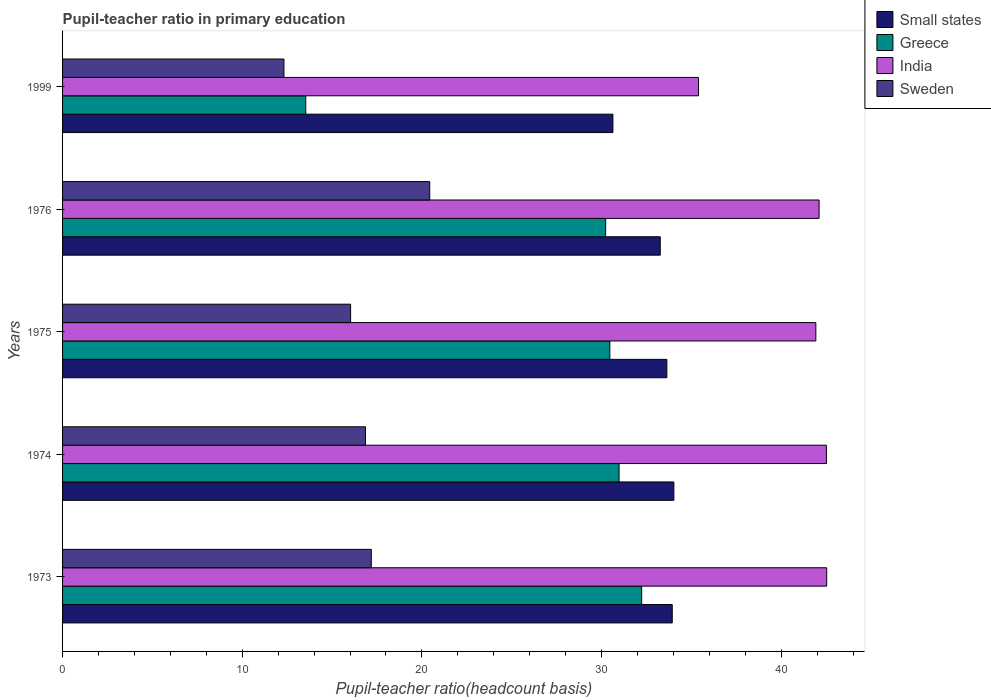Are the number of bars per tick equal to the number of legend labels?
Your answer should be very brief. Yes. Are the number of bars on each tick of the Y-axis equal?
Your answer should be very brief. Yes. How many bars are there on the 1st tick from the bottom?
Provide a short and direct response. 4. What is the label of the 5th group of bars from the top?
Ensure brevity in your answer.  1973. What is the pupil-teacher ratio in primary education in Small states in 1999?
Provide a succinct answer. 30.64. Across all years, what is the maximum pupil-teacher ratio in primary education in Small states?
Ensure brevity in your answer.  34.03. Across all years, what is the minimum pupil-teacher ratio in primary education in India?
Ensure brevity in your answer.  35.4. In which year was the pupil-teacher ratio in primary education in Small states maximum?
Provide a short and direct response. 1974. In which year was the pupil-teacher ratio in primary education in Small states minimum?
Your answer should be very brief. 1999. What is the total pupil-teacher ratio in primary education in India in the graph?
Make the answer very short. 204.5. What is the difference between the pupil-teacher ratio in primary education in Small states in 1973 and that in 1976?
Ensure brevity in your answer.  0.67. What is the difference between the pupil-teacher ratio in primary education in Small states in 1975 and the pupil-teacher ratio in primary education in India in 1976?
Ensure brevity in your answer.  -8.47. What is the average pupil-teacher ratio in primary education in Small states per year?
Give a very brief answer. 33.1. In the year 1975, what is the difference between the pupil-teacher ratio in primary education in India and pupil-teacher ratio in primary education in Sweden?
Give a very brief answer. 25.9. In how many years, is the pupil-teacher ratio in primary education in India greater than 40 ?
Your response must be concise. 4. What is the ratio of the pupil-teacher ratio in primary education in India in 1976 to that in 1999?
Your response must be concise. 1.19. Is the pupil-teacher ratio in primary education in Small states in 1973 less than that in 1976?
Give a very brief answer. No. Is the difference between the pupil-teacher ratio in primary education in India in 1973 and 1975 greater than the difference between the pupil-teacher ratio in primary education in Sweden in 1973 and 1975?
Give a very brief answer. No. What is the difference between the highest and the second highest pupil-teacher ratio in primary education in India?
Keep it short and to the point. 0.02. What is the difference between the highest and the lowest pupil-teacher ratio in primary education in India?
Keep it short and to the point. 7.14. In how many years, is the pupil-teacher ratio in primary education in Sweden greater than the average pupil-teacher ratio in primary education in Sweden taken over all years?
Make the answer very short. 3. Is the sum of the pupil-teacher ratio in primary education in Sweden in 1974 and 1975 greater than the maximum pupil-teacher ratio in primary education in Greece across all years?
Give a very brief answer. Yes. Is it the case that in every year, the sum of the pupil-teacher ratio in primary education in Sweden and pupil-teacher ratio in primary education in Greece is greater than the pupil-teacher ratio in primary education in Small states?
Provide a short and direct response. No. How many bars are there?
Make the answer very short. 20. How many years are there in the graph?
Ensure brevity in your answer.  5. What is the difference between two consecutive major ticks on the X-axis?
Give a very brief answer. 10. Are the values on the major ticks of X-axis written in scientific E-notation?
Offer a terse response. No. Does the graph contain grids?
Give a very brief answer. No. How are the legend labels stacked?
Give a very brief answer. Vertical. What is the title of the graph?
Offer a terse response. Pupil-teacher ratio in primary education. Does "Oman" appear as one of the legend labels in the graph?
Offer a very short reply. No. What is the label or title of the X-axis?
Ensure brevity in your answer.  Pupil-teacher ratio(headcount basis). What is the Pupil-teacher ratio(headcount basis) in Small states in 1973?
Provide a short and direct response. 33.94. What is the Pupil-teacher ratio(headcount basis) of Greece in 1973?
Provide a succinct answer. 32.24. What is the Pupil-teacher ratio(headcount basis) of India in 1973?
Your answer should be compact. 42.54. What is the Pupil-teacher ratio(headcount basis) of Sweden in 1973?
Ensure brevity in your answer.  17.19. What is the Pupil-teacher ratio(headcount basis) in Small states in 1974?
Your response must be concise. 34.03. What is the Pupil-teacher ratio(headcount basis) in Greece in 1974?
Offer a terse response. 30.98. What is the Pupil-teacher ratio(headcount basis) of India in 1974?
Provide a short and direct response. 42.52. What is the Pupil-teacher ratio(headcount basis) of Sweden in 1974?
Your answer should be very brief. 16.86. What is the Pupil-teacher ratio(headcount basis) in Small states in 1975?
Give a very brief answer. 33.64. What is the Pupil-teacher ratio(headcount basis) of Greece in 1975?
Your answer should be very brief. 30.46. What is the Pupil-teacher ratio(headcount basis) in India in 1975?
Give a very brief answer. 41.93. What is the Pupil-teacher ratio(headcount basis) of Sweden in 1975?
Your answer should be compact. 16.03. What is the Pupil-teacher ratio(headcount basis) of Small states in 1976?
Your answer should be compact. 33.27. What is the Pupil-teacher ratio(headcount basis) of Greece in 1976?
Make the answer very short. 30.23. What is the Pupil-teacher ratio(headcount basis) in India in 1976?
Make the answer very short. 42.11. What is the Pupil-teacher ratio(headcount basis) in Sweden in 1976?
Make the answer very short. 20.44. What is the Pupil-teacher ratio(headcount basis) in Small states in 1999?
Your answer should be compact. 30.64. What is the Pupil-teacher ratio(headcount basis) in Greece in 1999?
Make the answer very short. 13.54. What is the Pupil-teacher ratio(headcount basis) in India in 1999?
Ensure brevity in your answer.  35.4. What is the Pupil-teacher ratio(headcount basis) of Sweden in 1999?
Provide a succinct answer. 12.32. Across all years, what is the maximum Pupil-teacher ratio(headcount basis) of Small states?
Your answer should be compact. 34.03. Across all years, what is the maximum Pupil-teacher ratio(headcount basis) in Greece?
Your answer should be very brief. 32.24. Across all years, what is the maximum Pupil-teacher ratio(headcount basis) in India?
Offer a terse response. 42.54. Across all years, what is the maximum Pupil-teacher ratio(headcount basis) in Sweden?
Make the answer very short. 20.44. Across all years, what is the minimum Pupil-teacher ratio(headcount basis) of Small states?
Your answer should be compact. 30.64. Across all years, what is the minimum Pupil-teacher ratio(headcount basis) in Greece?
Your answer should be compact. 13.54. Across all years, what is the minimum Pupil-teacher ratio(headcount basis) in India?
Ensure brevity in your answer.  35.4. Across all years, what is the minimum Pupil-teacher ratio(headcount basis) in Sweden?
Your answer should be very brief. 12.32. What is the total Pupil-teacher ratio(headcount basis) of Small states in the graph?
Make the answer very short. 165.51. What is the total Pupil-teacher ratio(headcount basis) in Greece in the graph?
Offer a terse response. 137.45. What is the total Pupil-teacher ratio(headcount basis) in India in the graph?
Offer a very short reply. 204.5. What is the total Pupil-teacher ratio(headcount basis) in Sweden in the graph?
Provide a succinct answer. 82.84. What is the difference between the Pupil-teacher ratio(headcount basis) in Small states in 1973 and that in 1974?
Offer a terse response. -0.09. What is the difference between the Pupil-teacher ratio(headcount basis) in Greece in 1973 and that in 1974?
Your answer should be compact. 1.26. What is the difference between the Pupil-teacher ratio(headcount basis) of India in 1973 and that in 1974?
Make the answer very short. 0.02. What is the difference between the Pupil-teacher ratio(headcount basis) in Sweden in 1973 and that in 1974?
Ensure brevity in your answer.  0.32. What is the difference between the Pupil-teacher ratio(headcount basis) in Small states in 1973 and that in 1975?
Ensure brevity in your answer.  0.3. What is the difference between the Pupil-teacher ratio(headcount basis) in Greece in 1973 and that in 1975?
Your response must be concise. 1.77. What is the difference between the Pupil-teacher ratio(headcount basis) in India in 1973 and that in 1975?
Make the answer very short. 0.6. What is the difference between the Pupil-teacher ratio(headcount basis) in Sweden in 1973 and that in 1975?
Ensure brevity in your answer.  1.15. What is the difference between the Pupil-teacher ratio(headcount basis) in Small states in 1973 and that in 1976?
Give a very brief answer. 0.67. What is the difference between the Pupil-teacher ratio(headcount basis) in Greece in 1973 and that in 1976?
Make the answer very short. 2.01. What is the difference between the Pupil-teacher ratio(headcount basis) of India in 1973 and that in 1976?
Your answer should be very brief. 0.42. What is the difference between the Pupil-teacher ratio(headcount basis) of Sweden in 1973 and that in 1976?
Your response must be concise. -3.25. What is the difference between the Pupil-teacher ratio(headcount basis) of Small states in 1973 and that in 1999?
Provide a short and direct response. 3.3. What is the difference between the Pupil-teacher ratio(headcount basis) in Greece in 1973 and that in 1999?
Make the answer very short. 18.7. What is the difference between the Pupil-teacher ratio(headcount basis) of India in 1973 and that in 1999?
Your response must be concise. 7.14. What is the difference between the Pupil-teacher ratio(headcount basis) of Sweden in 1973 and that in 1999?
Keep it short and to the point. 4.86. What is the difference between the Pupil-teacher ratio(headcount basis) in Small states in 1974 and that in 1975?
Provide a short and direct response. 0.39. What is the difference between the Pupil-teacher ratio(headcount basis) in Greece in 1974 and that in 1975?
Your answer should be compact. 0.51. What is the difference between the Pupil-teacher ratio(headcount basis) in India in 1974 and that in 1975?
Give a very brief answer. 0.59. What is the difference between the Pupil-teacher ratio(headcount basis) of Sweden in 1974 and that in 1975?
Your answer should be very brief. 0.83. What is the difference between the Pupil-teacher ratio(headcount basis) in Small states in 1974 and that in 1976?
Offer a very short reply. 0.76. What is the difference between the Pupil-teacher ratio(headcount basis) in Greece in 1974 and that in 1976?
Provide a short and direct response. 0.75. What is the difference between the Pupil-teacher ratio(headcount basis) in India in 1974 and that in 1976?
Ensure brevity in your answer.  0.41. What is the difference between the Pupil-teacher ratio(headcount basis) in Sweden in 1974 and that in 1976?
Ensure brevity in your answer.  -3.58. What is the difference between the Pupil-teacher ratio(headcount basis) of Small states in 1974 and that in 1999?
Keep it short and to the point. 3.39. What is the difference between the Pupil-teacher ratio(headcount basis) of Greece in 1974 and that in 1999?
Provide a short and direct response. 17.44. What is the difference between the Pupil-teacher ratio(headcount basis) of India in 1974 and that in 1999?
Your answer should be very brief. 7.12. What is the difference between the Pupil-teacher ratio(headcount basis) in Sweden in 1974 and that in 1999?
Give a very brief answer. 4.54. What is the difference between the Pupil-teacher ratio(headcount basis) in Small states in 1975 and that in 1976?
Your answer should be very brief. 0.37. What is the difference between the Pupil-teacher ratio(headcount basis) in Greece in 1975 and that in 1976?
Provide a short and direct response. 0.23. What is the difference between the Pupil-teacher ratio(headcount basis) in India in 1975 and that in 1976?
Provide a succinct answer. -0.18. What is the difference between the Pupil-teacher ratio(headcount basis) of Sweden in 1975 and that in 1976?
Keep it short and to the point. -4.4. What is the difference between the Pupil-teacher ratio(headcount basis) of Small states in 1975 and that in 1999?
Your answer should be compact. 3. What is the difference between the Pupil-teacher ratio(headcount basis) of Greece in 1975 and that in 1999?
Your answer should be very brief. 16.93. What is the difference between the Pupil-teacher ratio(headcount basis) in India in 1975 and that in 1999?
Ensure brevity in your answer.  6.53. What is the difference between the Pupil-teacher ratio(headcount basis) in Sweden in 1975 and that in 1999?
Give a very brief answer. 3.71. What is the difference between the Pupil-teacher ratio(headcount basis) of Small states in 1976 and that in 1999?
Keep it short and to the point. 2.63. What is the difference between the Pupil-teacher ratio(headcount basis) of Greece in 1976 and that in 1999?
Offer a very short reply. 16.69. What is the difference between the Pupil-teacher ratio(headcount basis) in India in 1976 and that in 1999?
Keep it short and to the point. 6.71. What is the difference between the Pupil-teacher ratio(headcount basis) of Sweden in 1976 and that in 1999?
Ensure brevity in your answer.  8.12. What is the difference between the Pupil-teacher ratio(headcount basis) of Small states in 1973 and the Pupil-teacher ratio(headcount basis) of Greece in 1974?
Ensure brevity in your answer.  2.96. What is the difference between the Pupil-teacher ratio(headcount basis) in Small states in 1973 and the Pupil-teacher ratio(headcount basis) in India in 1974?
Provide a succinct answer. -8.58. What is the difference between the Pupil-teacher ratio(headcount basis) in Small states in 1973 and the Pupil-teacher ratio(headcount basis) in Sweden in 1974?
Your response must be concise. 17.08. What is the difference between the Pupil-teacher ratio(headcount basis) of Greece in 1973 and the Pupil-teacher ratio(headcount basis) of India in 1974?
Offer a very short reply. -10.28. What is the difference between the Pupil-teacher ratio(headcount basis) of Greece in 1973 and the Pupil-teacher ratio(headcount basis) of Sweden in 1974?
Your response must be concise. 15.37. What is the difference between the Pupil-teacher ratio(headcount basis) in India in 1973 and the Pupil-teacher ratio(headcount basis) in Sweden in 1974?
Keep it short and to the point. 25.67. What is the difference between the Pupil-teacher ratio(headcount basis) of Small states in 1973 and the Pupil-teacher ratio(headcount basis) of Greece in 1975?
Your answer should be compact. 3.47. What is the difference between the Pupil-teacher ratio(headcount basis) of Small states in 1973 and the Pupil-teacher ratio(headcount basis) of India in 1975?
Offer a terse response. -7.99. What is the difference between the Pupil-teacher ratio(headcount basis) in Small states in 1973 and the Pupil-teacher ratio(headcount basis) in Sweden in 1975?
Your answer should be very brief. 17.9. What is the difference between the Pupil-teacher ratio(headcount basis) in Greece in 1973 and the Pupil-teacher ratio(headcount basis) in India in 1975?
Your answer should be compact. -9.7. What is the difference between the Pupil-teacher ratio(headcount basis) in Greece in 1973 and the Pupil-teacher ratio(headcount basis) in Sweden in 1975?
Your answer should be compact. 16.2. What is the difference between the Pupil-teacher ratio(headcount basis) in India in 1973 and the Pupil-teacher ratio(headcount basis) in Sweden in 1975?
Provide a short and direct response. 26.5. What is the difference between the Pupil-teacher ratio(headcount basis) of Small states in 1973 and the Pupil-teacher ratio(headcount basis) of Greece in 1976?
Give a very brief answer. 3.71. What is the difference between the Pupil-teacher ratio(headcount basis) in Small states in 1973 and the Pupil-teacher ratio(headcount basis) in India in 1976?
Keep it short and to the point. -8.18. What is the difference between the Pupil-teacher ratio(headcount basis) in Small states in 1973 and the Pupil-teacher ratio(headcount basis) in Sweden in 1976?
Ensure brevity in your answer.  13.5. What is the difference between the Pupil-teacher ratio(headcount basis) of Greece in 1973 and the Pupil-teacher ratio(headcount basis) of India in 1976?
Offer a very short reply. -9.88. What is the difference between the Pupil-teacher ratio(headcount basis) in Greece in 1973 and the Pupil-teacher ratio(headcount basis) in Sweden in 1976?
Your response must be concise. 11.8. What is the difference between the Pupil-teacher ratio(headcount basis) of India in 1973 and the Pupil-teacher ratio(headcount basis) of Sweden in 1976?
Ensure brevity in your answer.  22.1. What is the difference between the Pupil-teacher ratio(headcount basis) of Small states in 1973 and the Pupil-teacher ratio(headcount basis) of Greece in 1999?
Keep it short and to the point. 20.4. What is the difference between the Pupil-teacher ratio(headcount basis) of Small states in 1973 and the Pupil-teacher ratio(headcount basis) of India in 1999?
Keep it short and to the point. -1.46. What is the difference between the Pupil-teacher ratio(headcount basis) in Small states in 1973 and the Pupil-teacher ratio(headcount basis) in Sweden in 1999?
Provide a succinct answer. 21.62. What is the difference between the Pupil-teacher ratio(headcount basis) in Greece in 1973 and the Pupil-teacher ratio(headcount basis) in India in 1999?
Give a very brief answer. -3.16. What is the difference between the Pupil-teacher ratio(headcount basis) in Greece in 1973 and the Pupil-teacher ratio(headcount basis) in Sweden in 1999?
Keep it short and to the point. 19.91. What is the difference between the Pupil-teacher ratio(headcount basis) of India in 1973 and the Pupil-teacher ratio(headcount basis) of Sweden in 1999?
Ensure brevity in your answer.  30.21. What is the difference between the Pupil-teacher ratio(headcount basis) of Small states in 1974 and the Pupil-teacher ratio(headcount basis) of Greece in 1975?
Give a very brief answer. 3.56. What is the difference between the Pupil-teacher ratio(headcount basis) in Small states in 1974 and the Pupil-teacher ratio(headcount basis) in India in 1975?
Your response must be concise. -7.9. What is the difference between the Pupil-teacher ratio(headcount basis) of Small states in 1974 and the Pupil-teacher ratio(headcount basis) of Sweden in 1975?
Make the answer very short. 17.99. What is the difference between the Pupil-teacher ratio(headcount basis) in Greece in 1974 and the Pupil-teacher ratio(headcount basis) in India in 1975?
Offer a terse response. -10.95. What is the difference between the Pupil-teacher ratio(headcount basis) of Greece in 1974 and the Pupil-teacher ratio(headcount basis) of Sweden in 1975?
Offer a very short reply. 14.94. What is the difference between the Pupil-teacher ratio(headcount basis) in India in 1974 and the Pupil-teacher ratio(headcount basis) in Sweden in 1975?
Give a very brief answer. 26.49. What is the difference between the Pupil-teacher ratio(headcount basis) of Small states in 1974 and the Pupil-teacher ratio(headcount basis) of Greece in 1976?
Keep it short and to the point. 3.8. What is the difference between the Pupil-teacher ratio(headcount basis) of Small states in 1974 and the Pupil-teacher ratio(headcount basis) of India in 1976?
Give a very brief answer. -8.09. What is the difference between the Pupil-teacher ratio(headcount basis) in Small states in 1974 and the Pupil-teacher ratio(headcount basis) in Sweden in 1976?
Provide a succinct answer. 13.59. What is the difference between the Pupil-teacher ratio(headcount basis) in Greece in 1974 and the Pupil-teacher ratio(headcount basis) in India in 1976?
Give a very brief answer. -11.14. What is the difference between the Pupil-teacher ratio(headcount basis) of Greece in 1974 and the Pupil-teacher ratio(headcount basis) of Sweden in 1976?
Ensure brevity in your answer.  10.54. What is the difference between the Pupil-teacher ratio(headcount basis) of India in 1974 and the Pupil-teacher ratio(headcount basis) of Sweden in 1976?
Give a very brief answer. 22.08. What is the difference between the Pupil-teacher ratio(headcount basis) in Small states in 1974 and the Pupil-teacher ratio(headcount basis) in Greece in 1999?
Give a very brief answer. 20.49. What is the difference between the Pupil-teacher ratio(headcount basis) in Small states in 1974 and the Pupil-teacher ratio(headcount basis) in India in 1999?
Provide a succinct answer. -1.37. What is the difference between the Pupil-teacher ratio(headcount basis) in Small states in 1974 and the Pupil-teacher ratio(headcount basis) in Sweden in 1999?
Your answer should be compact. 21.7. What is the difference between the Pupil-teacher ratio(headcount basis) in Greece in 1974 and the Pupil-teacher ratio(headcount basis) in India in 1999?
Provide a succinct answer. -4.42. What is the difference between the Pupil-teacher ratio(headcount basis) in Greece in 1974 and the Pupil-teacher ratio(headcount basis) in Sweden in 1999?
Provide a succinct answer. 18.65. What is the difference between the Pupil-teacher ratio(headcount basis) in India in 1974 and the Pupil-teacher ratio(headcount basis) in Sweden in 1999?
Offer a very short reply. 30.2. What is the difference between the Pupil-teacher ratio(headcount basis) in Small states in 1975 and the Pupil-teacher ratio(headcount basis) in Greece in 1976?
Offer a terse response. 3.41. What is the difference between the Pupil-teacher ratio(headcount basis) in Small states in 1975 and the Pupil-teacher ratio(headcount basis) in India in 1976?
Your response must be concise. -8.47. What is the difference between the Pupil-teacher ratio(headcount basis) in Small states in 1975 and the Pupil-teacher ratio(headcount basis) in Sweden in 1976?
Ensure brevity in your answer.  13.2. What is the difference between the Pupil-teacher ratio(headcount basis) in Greece in 1975 and the Pupil-teacher ratio(headcount basis) in India in 1976?
Give a very brief answer. -11.65. What is the difference between the Pupil-teacher ratio(headcount basis) in Greece in 1975 and the Pupil-teacher ratio(headcount basis) in Sweden in 1976?
Ensure brevity in your answer.  10.03. What is the difference between the Pupil-teacher ratio(headcount basis) in India in 1975 and the Pupil-teacher ratio(headcount basis) in Sweden in 1976?
Offer a very short reply. 21.49. What is the difference between the Pupil-teacher ratio(headcount basis) of Small states in 1975 and the Pupil-teacher ratio(headcount basis) of Greece in 1999?
Offer a very short reply. 20.1. What is the difference between the Pupil-teacher ratio(headcount basis) in Small states in 1975 and the Pupil-teacher ratio(headcount basis) in India in 1999?
Your answer should be very brief. -1.76. What is the difference between the Pupil-teacher ratio(headcount basis) in Small states in 1975 and the Pupil-teacher ratio(headcount basis) in Sweden in 1999?
Your answer should be very brief. 21.32. What is the difference between the Pupil-teacher ratio(headcount basis) in Greece in 1975 and the Pupil-teacher ratio(headcount basis) in India in 1999?
Make the answer very short. -4.94. What is the difference between the Pupil-teacher ratio(headcount basis) of Greece in 1975 and the Pupil-teacher ratio(headcount basis) of Sweden in 1999?
Your response must be concise. 18.14. What is the difference between the Pupil-teacher ratio(headcount basis) of India in 1975 and the Pupil-teacher ratio(headcount basis) of Sweden in 1999?
Your answer should be very brief. 29.61. What is the difference between the Pupil-teacher ratio(headcount basis) of Small states in 1976 and the Pupil-teacher ratio(headcount basis) of Greece in 1999?
Keep it short and to the point. 19.73. What is the difference between the Pupil-teacher ratio(headcount basis) in Small states in 1976 and the Pupil-teacher ratio(headcount basis) in India in 1999?
Your answer should be very brief. -2.13. What is the difference between the Pupil-teacher ratio(headcount basis) in Small states in 1976 and the Pupil-teacher ratio(headcount basis) in Sweden in 1999?
Your response must be concise. 20.95. What is the difference between the Pupil-teacher ratio(headcount basis) in Greece in 1976 and the Pupil-teacher ratio(headcount basis) in India in 1999?
Your response must be concise. -5.17. What is the difference between the Pupil-teacher ratio(headcount basis) of Greece in 1976 and the Pupil-teacher ratio(headcount basis) of Sweden in 1999?
Your response must be concise. 17.91. What is the difference between the Pupil-teacher ratio(headcount basis) in India in 1976 and the Pupil-teacher ratio(headcount basis) in Sweden in 1999?
Give a very brief answer. 29.79. What is the average Pupil-teacher ratio(headcount basis) in Small states per year?
Your response must be concise. 33.1. What is the average Pupil-teacher ratio(headcount basis) in Greece per year?
Ensure brevity in your answer.  27.49. What is the average Pupil-teacher ratio(headcount basis) of India per year?
Your response must be concise. 40.9. What is the average Pupil-teacher ratio(headcount basis) in Sweden per year?
Provide a succinct answer. 16.57. In the year 1973, what is the difference between the Pupil-teacher ratio(headcount basis) of Small states and Pupil-teacher ratio(headcount basis) of Greece?
Make the answer very short. 1.7. In the year 1973, what is the difference between the Pupil-teacher ratio(headcount basis) of Small states and Pupil-teacher ratio(headcount basis) of India?
Your answer should be compact. -8.6. In the year 1973, what is the difference between the Pupil-teacher ratio(headcount basis) of Small states and Pupil-teacher ratio(headcount basis) of Sweden?
Give a very brief answer. 16.75. In the year 1973, what is the difference between the Pupil-teacher ratio(headcount basis) in Greece and Pupil-teacher ratio(headcount basis) in India?
Your response must be concise. -10.3. In the year 1973, what is the difference between the Pupil-teacher ratio(headcount basis) of Greece and Pupil-teacher ratio(headcount basis) of Sweden?
Ensure brevity in your answer.  15.05. In the year 1973, what is the difference between the Pupil-teacher ratio(headcount basis) of India and Pupil-teacher ratio(headcount basis) of Sweden?
Offer a terse response. 25.35. In the year 1974, what is the difference between the Pupil-teacher ratio(headcount basis) of Small states and Pupil-teacher ratio(headcount basis) of Greece?
Offer a terse response. 3.05. In the year 1974, what is the difference between the Pupil-teacher ratio(headcount basis) in Small states and Pupil-teacher ratio(headcount basis) in India?
Keep it short and to the point. -8.49. In the year 1974, what is the difference between the Pupil-teacher ratio(headcount basis) of Small states and Pupil-teacher ratio(headcount basis) of Sweden?
Ensure brevity in your answer.  17.17. In the year 1974, what is the difference between the Pupil-teacher ratio(headcount basis) of Greece and Pupil-teacher ratio(headcount basis) of India?
Offer a very short reply. -11.54. In the year 1974, what is the difference between the Pupil-teacher ratio(headcount basis) in Greece and Pupil-teacher ratio(headcount basis) in Sweden?
Offer a terse response. 14.12. In the year 1974, what is the difference between the Pupil-teacher ratio(headcount basis) in India and Pupil-teacher ratio(headcount basis) in Sweden?
Offer a very short reply. 25.66. In the year 1975, what is the difference between the Pupil-teacher ratio(headcount basis) of Small states and Pupil-teacher ratio(headcount basis) of Greece?
Provide a succinct answer. 3.18. In the year 1975, what is the difference between the Pupil-teacher ratio(headcount basis) of Small states and Pupil-teacher ratio(headcount basis) of India?
Provide a short and direct response. -8.29. In the year 1975, what is the difference between the Pupil-teacher ratio(headcount basis) in Small states and Pupil-teacher ratio(headcount basis) in Sweden?
Make the answer very short. 17.6. In the year 1975, what is the difference between the Pupil-teacher ratio(headcount basis) of Greece and Pupil-teacher ratio(headcount basis) of India?
Ensure brevity in your answer.  -11.47. In the year 1975, what is the difference between the Pupil-teacher ratio(headcount basis) of Greece and Pupil-teacher ratio(headcount basis) of Sweden?
Provide a short and direct response. 14.43. In the year 1975, what is the difference between the Pupil-teacher ratio(headcount basis) of India and Pupil-teacher ratio(headcount basis) of Sweden?
Make the answer very short. 25.9. In the year 1976, what is the difference between the Pupil-teacher ratio(headcount basis) of Small states and Pupil-teacher ratio(headcount basis) of Greece?
Offer a terse response. 3.04. In the year 1976, what is the difference between the Pupil-teacher ratio(headcount basis) of Small states and Pupil-teacher ratio(headcount basis) of India?
Ensure brevity in your answer.  -8.84. In the year 1976, what is the difference between the Pupil-teacher ratio(headcount basis) in Small states and Pupil-teacher ratio(headcount basis) in Sweden?
Make the answer very short. 12.83. In the year 1976, what is the difference between the Pupil-teacher ratio(headcount basis) in Greece and Pupil-teacher ratio(headcount basis) in India?
Your answer should be compact. -11.88. In the year 1976, what is the difference between the Pupil-teacher ratio(headcount basis) in Greece and Pupil-teacher ratio(headcount basis) in Sweden?
Your answer should be very brief. 9.79. In the year 1976, what is the difference between the Pupil-teacher ratio(headcount basis) of India and Pupil-teacher ratio(headcount basis) of Sweden?
Keep it short and to the point. 21.67. In the year 1999, what is the difference between the Pupil-teacher ratio(headcount basis) of Small states and Pupil-teacher ratio(headcount basis) of Greece?
Ensure brevity in your answer.  17.1. In the year 1999, what is the difference between the Pupil-teacher ratio(headcount basis) of Small states and Pupil-teacher ratio(headcount basis) of India?
Make the answer very short. -4.76. In the year 1999, what is the difference between the Pupil-teacher ratio(headcount basis) of Small states and Pupil-teacher ratio(headcount basis) of Sweden?
Provide a succinct answer. 18.31. In the year 1999, what is the difference between the Pupil-teacher ratio(headcount basis) in Greece and Pupil-teacher ratio(headcount basis) in India?
Offer a terse response. -21.86. In the year 1999, what is the difference between the Pupil-teacher ratio(headcount basis) in Greece and Pupil-teacher ratio(headcount basis) in Sweden?
Your answer should be very brief. 1.22. In the year 1999, what is the difference between the Pupil-teacher ratio(headcount basis) of India and Pupil-teacher ratio(headcount basis) of Sweden?
Make the answer very short. 23.08. What is the ratio of the Pupil-teacher ratio(headcount basis) in Greece in 1973 to that in 1974?
Keep it short and to the point. 1.04. What is the ratio of the Pupil-teacher ratio(headcount basis) of Sweden in 1973 to that in 1974?
Provide a short and direct response. 1.02. What is the ratio of the Pupil-teacher ratio(headcount basis) of Small states in 1973 to that in 1975?
Your response must be concise. 1.01. What is the ratio of the Pupil-teacher ratio(headcount basis) in Greece in 1973 to that in 1975?
Offer a very short reply. 1.06. What is the ratio of the Pupil-teacher ratio(headcount basis) of India in 1973 to that in 1975?
Provide a succinct answer. 1.01. What is the ratio of the Pupil-teacher ratio(headcount basis) of Sweden in 1973 to that in 1975?
Provide a short and direct response. 1.07. What is the ratio of the Pupil-teacher ratio(headcount basis) in Small states in 1973 to that in 1976?
Your answer should be compact. 1.02. What is the ratio of the Pupil-teacher ratio(headcount basis) of Greece in 1973 to that in 1976?
Offer a terse response. 1.07. What is the ratio of the Pupil-teacher ratio(headcount basis) of Sweden in 1973 to that in 1976?
Your response must be concise. 0.84. What is the ratio of the Pupil-teacher ratio(headcount basis) of Small states in 1973 to that in 1999?
Keep it short and to the point. 1.11. What is the ratio of the Pupil-teacher ratio(headcount basis) in Greece in 1973 to that in 1999?
Offer a terse response. 2.38. What is the ratio of the Pupil-teacher ratio(headcount basis) in India in 1973 to that in 1999?
Your answer should be compact. 1.2. What is the ratio of the Pupil-teacher ratio(headcount basis) in Sweden in 1973 to that in 1999?
Give a very brief answer. 1.39. What is the ratio of the Pupil-teacher ratio(headcount basis) of Small states in 1974 to that in 1975?
Offer a very short reply. 1.01. What is the ratio of the Pupil-teacher ratio(headcount basis) in Greece in 1974 to that in 1975?
Make the answer very short. 1.02. What is the ratio of the Pupil-teacher ratio(headcount basis) in India in 1974 to that in 1975?
Provide a short and direct response. 1.01. What is the ratio of the Pupil-teacher ratio(headcount basis) of Sweden in 1974 to that in 1975?
Your response must be concise. 1.05. What is the ratio of the Pupil-teacher ratio(headcount basis) in Small states in 1974 to that in 1976?
Ensure brevity in your answer.  1.02. What is the ratio of the Pupil-teacher ratio(headcount basis) of Greece in 1974 to that in 1976?
Make the answer very short. 1.02. What is the ratio of the Pupil-teacher ratio(headcount basis) of India in 1974 to that in 1976?
Make the answer very short. 1.01. What is the ratio of the Pupil-teacher ratio(headcount basis) in Sweden in 1974 to that in 1976?
Your answer should be very brief. 0.82. What is the ratio of the Pupil-teacher ratio(headcount basis) in Small states in 1974 to that in 1999?
Ensure brevity in your answer.  1.11. What is the ratio of the Pupil-teacher ratio(headcount basis) of Greece in 1974 to that in 1999?
Ensure brevity in your answer.  2.29. What is the ratio of the Pupil-teacher ratio(headcount basis) of India in 1974 to that in 1999?
Make the answer very short. 1.2. What is the ratio of the Pupil-teacher ratio(headcount basis) in Sweden in 1974 to that in 1999?
Offer a very short reply. 1.37. What is the ratio of the Pupil-teacher ratio(headcount basis) of Small states in 1975 to that in 1976?
Offer a very short reply. 1.01. What is the ratio of the Pupil-teacher ratio(headcount basis) of Greece in 1975 to that in 1976?
Provide a succinct answer. 1.01. What is the ratio of the Pupil-teacher ratio(headcount basis) in India in 1975 to that in 1976?
Make the answer very short. 1. What is the ratio of the Pupil-teacher ratio(headcount basis) of Sweden in 1975 to that in 1976?
Your response must be concise. 0.78. What is the ratio of the Pupil-teacher ratio(headcount basis) of Small states in 1975 to that in 1999?
Keep it short and to the point. 1.1. What is the ratio of the Pupil-teacher ratio(headcount basis) in Greece in 1975 to that in 1999?
Your answer should be compact. 2.25. What is the ratio of the Pupil-teacher ratio(headcount basis) of India in 1975 to that in 1999?
Make the answer very short. 1.18. What is the ratio of the Pupil-teacher ratio(headcount basis) in Sweden in 1975 to that in 1999?
Make the answer very short. 1.3. What is the ratio of the Pupil-teacher ratio(headcount basis) in Small states in 1976 to that in 1999?
Offer a very short reply. 1.09. What is the ratio of the Pupil-teacher ratio(headcount basis) in Greece in 1976 to that in 1999?
Give a very brief answer. 2.23. What is the ratio of the Pupil-teacher ratio(headcount basis) in India in 1976 to that in 1999?
Offer a terse response. 1.19. What is the ratio of the Pupil-teacher ratio(headcount basis) of Sweden in 1976 to that in 1999?
Your answer should be compact. 1.66. What is the difference between the highest and the second highest Pupil-teacher ratio(headcount basis) in Small states?
Your answer should be compact. 0.09. What is the difference between the highest and the second highest Pupil-teacher ratio(headcount basis) in Greece?
Provide a short and direct response. 1.26. What is the difference between the highest and the second highest Pupil-teacher ratio(headcount basis) in India?
Offer a terse response. 0.02. What is the difference between the highest and the second highest Pupil-teacher ratio(headcount basis) in Sweden?
Your answer should be compact. 3.25. What is the difference between the highest and the lowest Pupil-teacher ratio(headcount basis) in Small states?
Provide a succinct answer. 3.39. What is the difference between the highest and the lowest Pupil-teacher ratio(headcount basis) of Greece?
Make the answer very short. 18.7. What is the difference between the highest and the lowest Pupil-teacher ratio(headcount basis) in India?
Provide a short and direct response. 7.14. What is the difference between the highest and the lowest Pupil-teacher ratio(headcount basis) of Sweden?
Offer a very short reply. 8.12. 